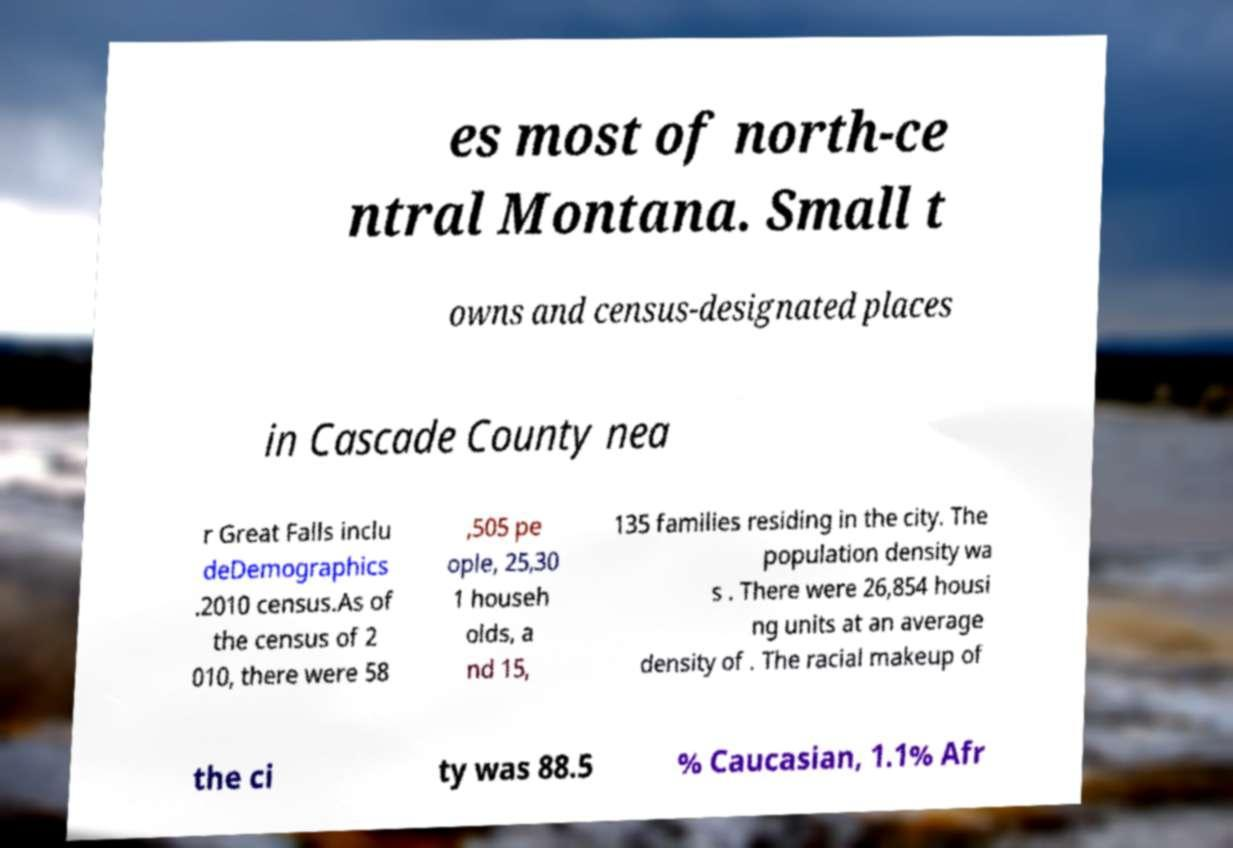Can you read and provide the text displayed in the image?This photo seems to have some interesting text. Can you extract and type it out for me? es most of north-ce ntral Montana. Small t owns and census-designated places in Cascade County nea r Great Falls inclu deDemographics .2010 census.As of the census of 2 010, there were 58 ,505 pe ople, 25,30 1 househ olds, a nd 15, 135 families residing in the city. The population density wa s . There were 26,854 housi ng units at an average density of . The racial makeup of the ci ty was 88.5 % Caucasian, 1.1% Afr 